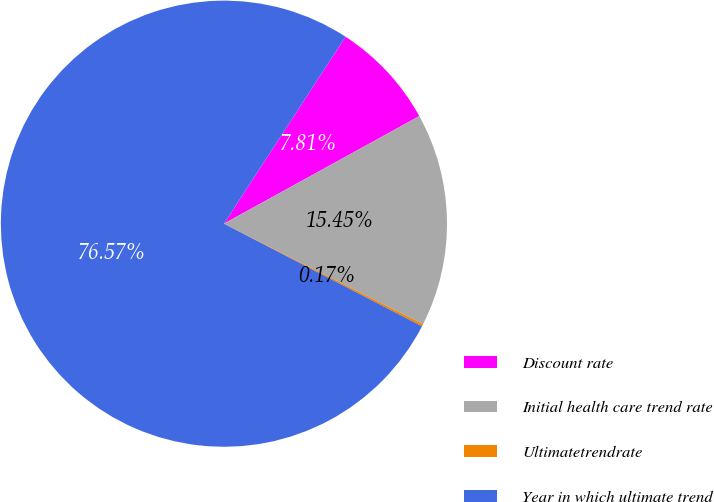<chart> <loc_0><loc_0><loc_500><loc_500><pie_chart><fcel>Discount rate<fcel>Initial health care trend rate<fcel>Ultimatetrendrate<fcel>Year in which ultimate trend<nl><fcel>7.81%<fcel>15.45%<fcel>0.17%<fcel>76.57%<nl></chart> 